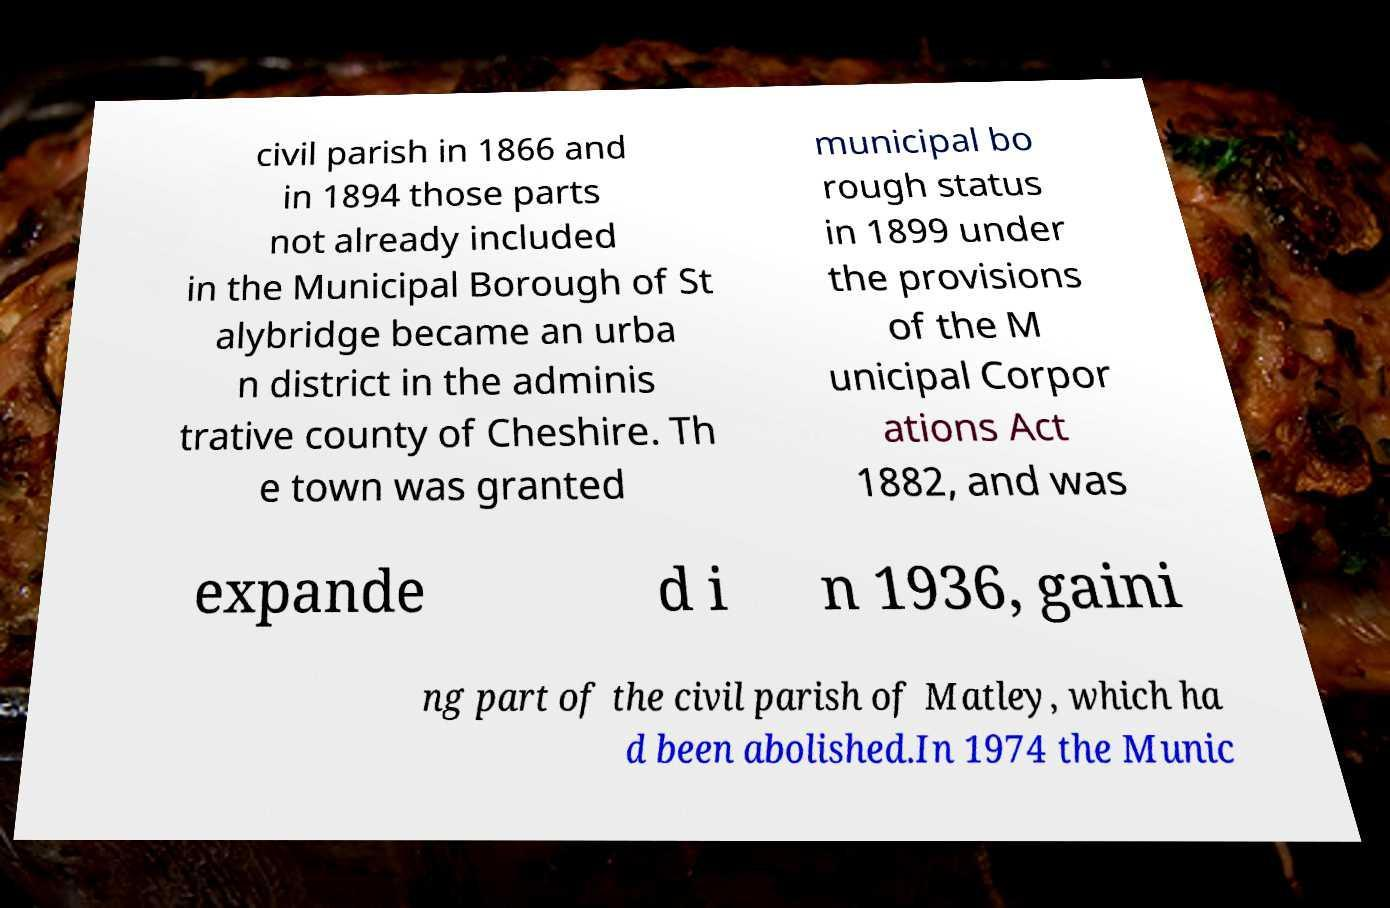Could you assist in decoding the text presented in this image and type it out clearly? civil parish in 1866 and in 1894 those parts not already included in the Municipal Borough of St alybridge became an urba n district in the adminis trative county of Cheshire. Th e town was granted municipal bo rough status in 1899 under the provisions of the M unicipal Corpor ations Act 1882, and was expande d i n 1936, gaini ng part of the civil parish of Matley, which ha d been abolished.In 1974 the Munic 